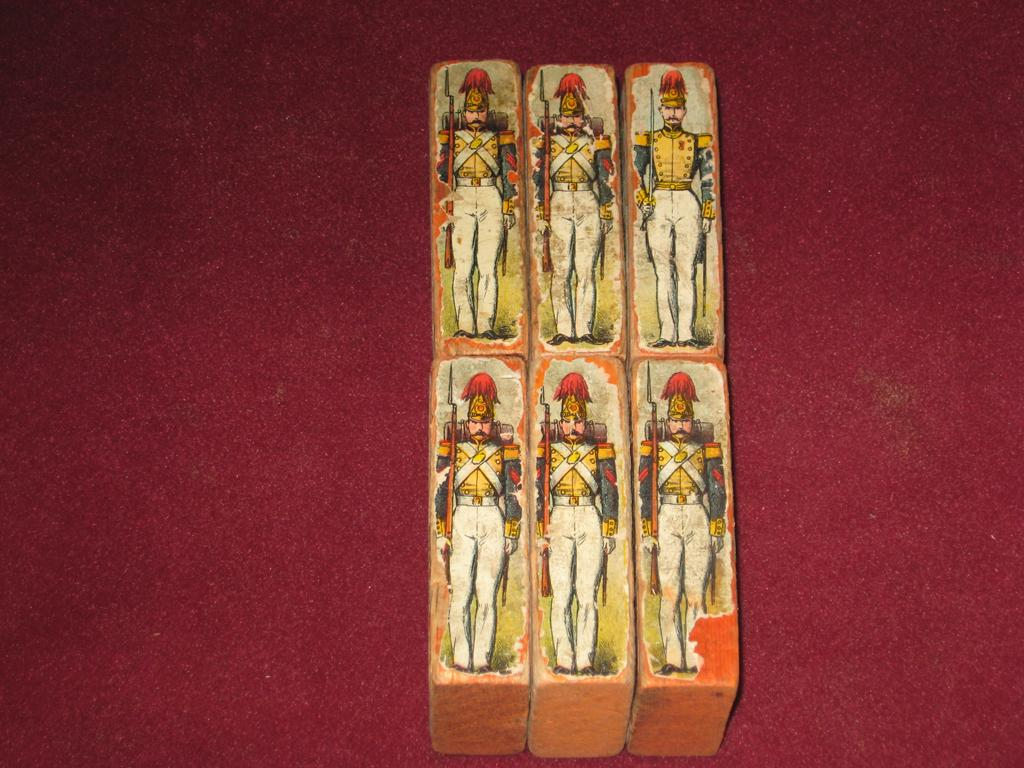What type of objects are in the image? There are wooden blocks in the image. What is on the wooden blocks? Stickers are attached to the wooden blocks. What color is the surface on which the wooden blocks and stickers are placed? The wooden blocks and stickers are on a maroon color surface. What type of calendar is displayed on the wooden blocks? There is no calendar present on the wooden blocks in the image. What kind of tooth is visible on the maroon surface? There is no tooth present on the maroon surface in the image. 